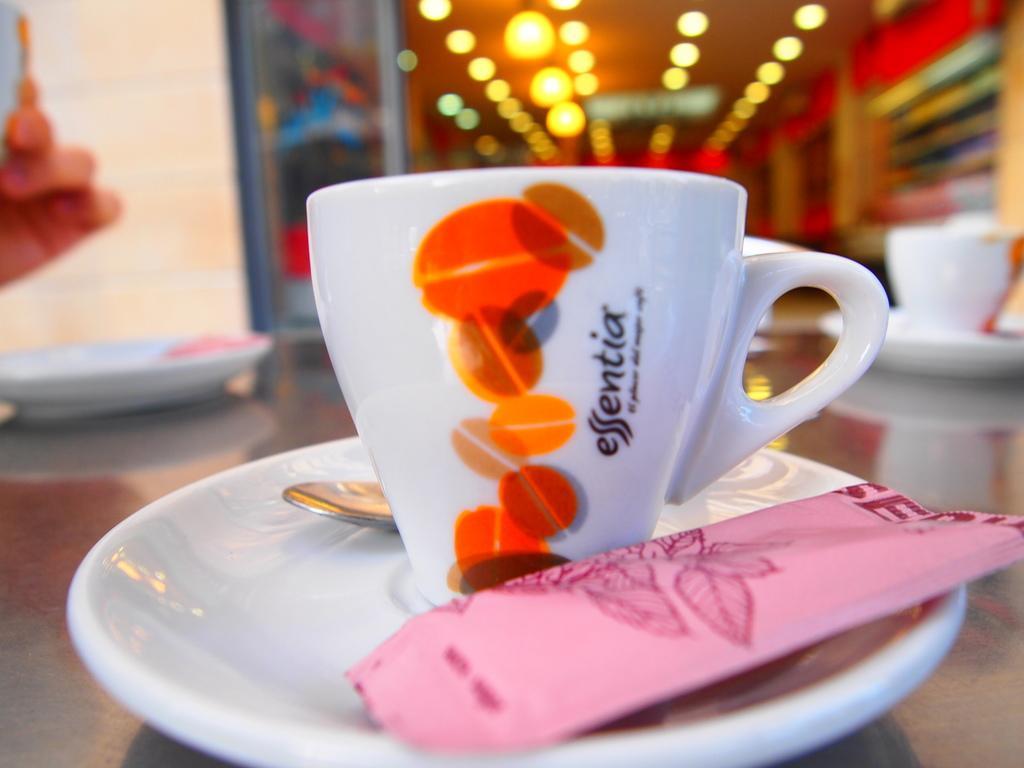How would you summarize this image in a sentence or two? In this image, there are a few cups and saucers. We can also see the ground. We can see a spoon and also a pink colored object. We can see the blurred background and also an object on the left. 